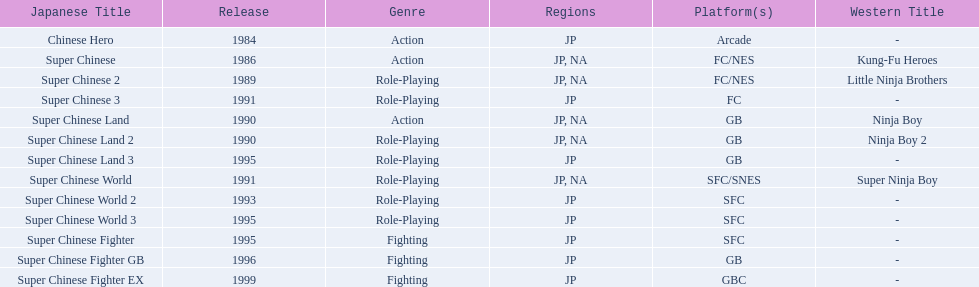How many action games have been introduced in north america? 2. 